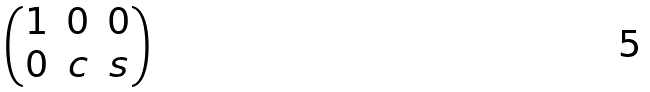<formula> <loc_0><loc_0><loc_500><loc_500>\begin{pmatrix} 1 & 0 & 0 \\ 0 & c & s \end{pmatrix}</formula> 